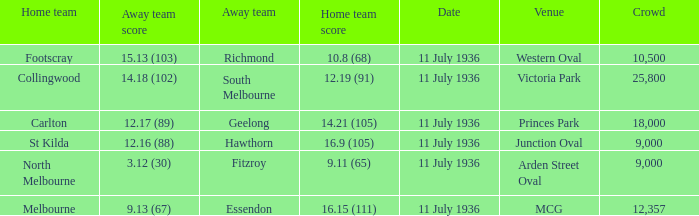What Away team got a team score of 12.16 (88)? Hawthorn. 